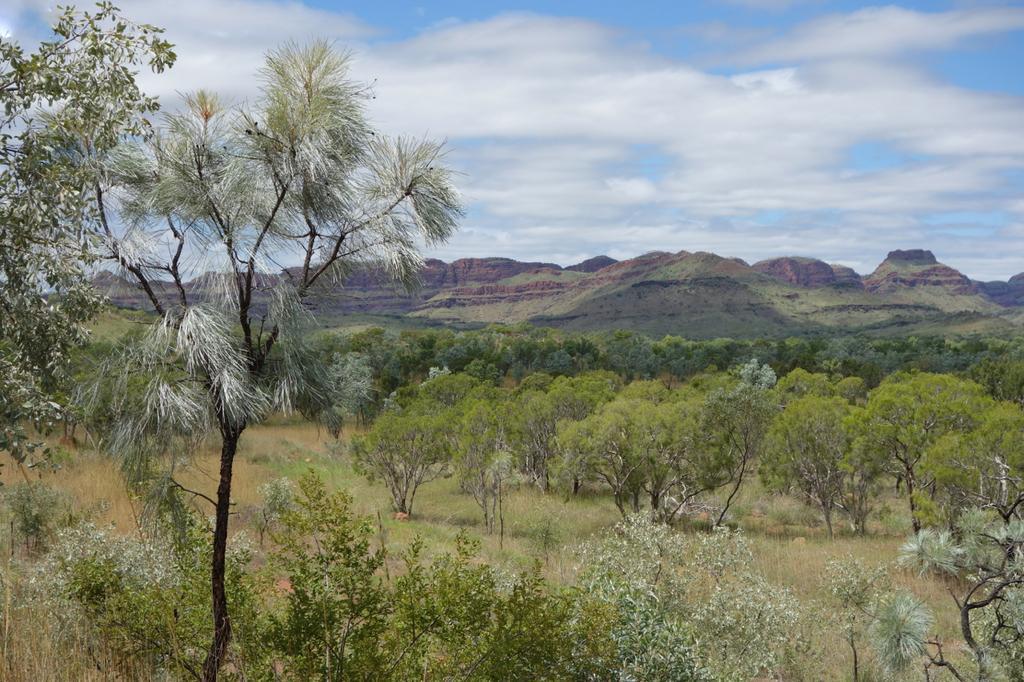How would you summarize this image in a sentence or two? In the image we can see a group of trees, grass. In the background, we can see mountains and the cloudy sky. 